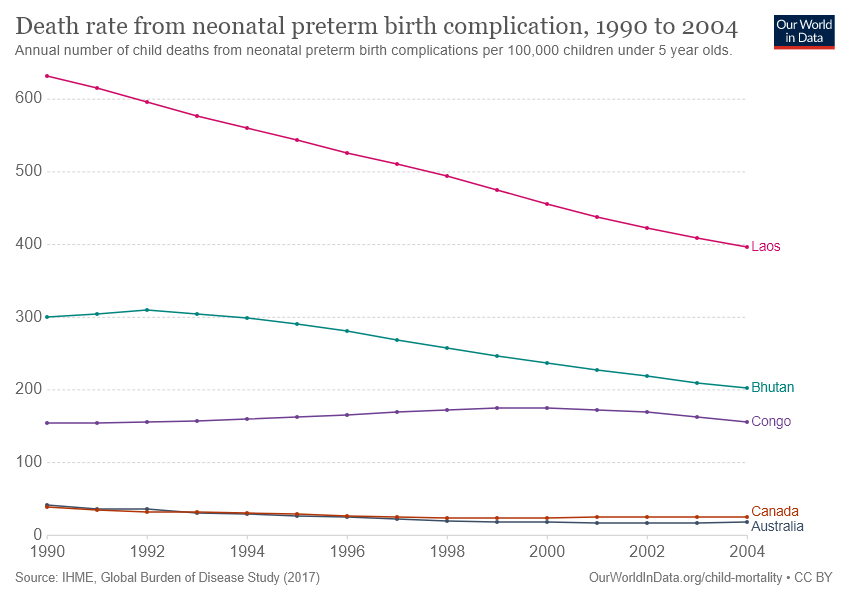Give some essential details in this illustration. In 1990, a total of three lines attained the peak. The green line reached its peak in 1992. 